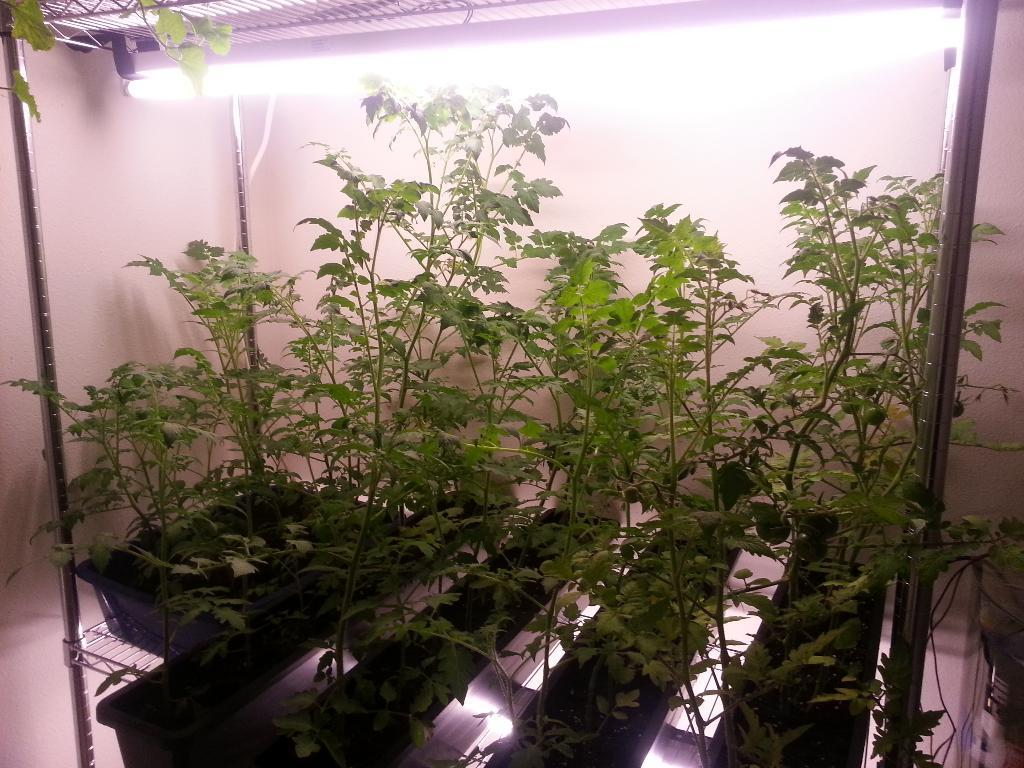What type of objects are present in the image that are used for holding plants? There are plant pots in the image. What type of material is used for the rods in the image? There are metal rods in the image. What is the source of light in the image? There is a light at the top of the image. What is the background of the image? There is a wall at the back of the image. What class is being taught in the image? There is no class or teaching activity depicted in the image. 